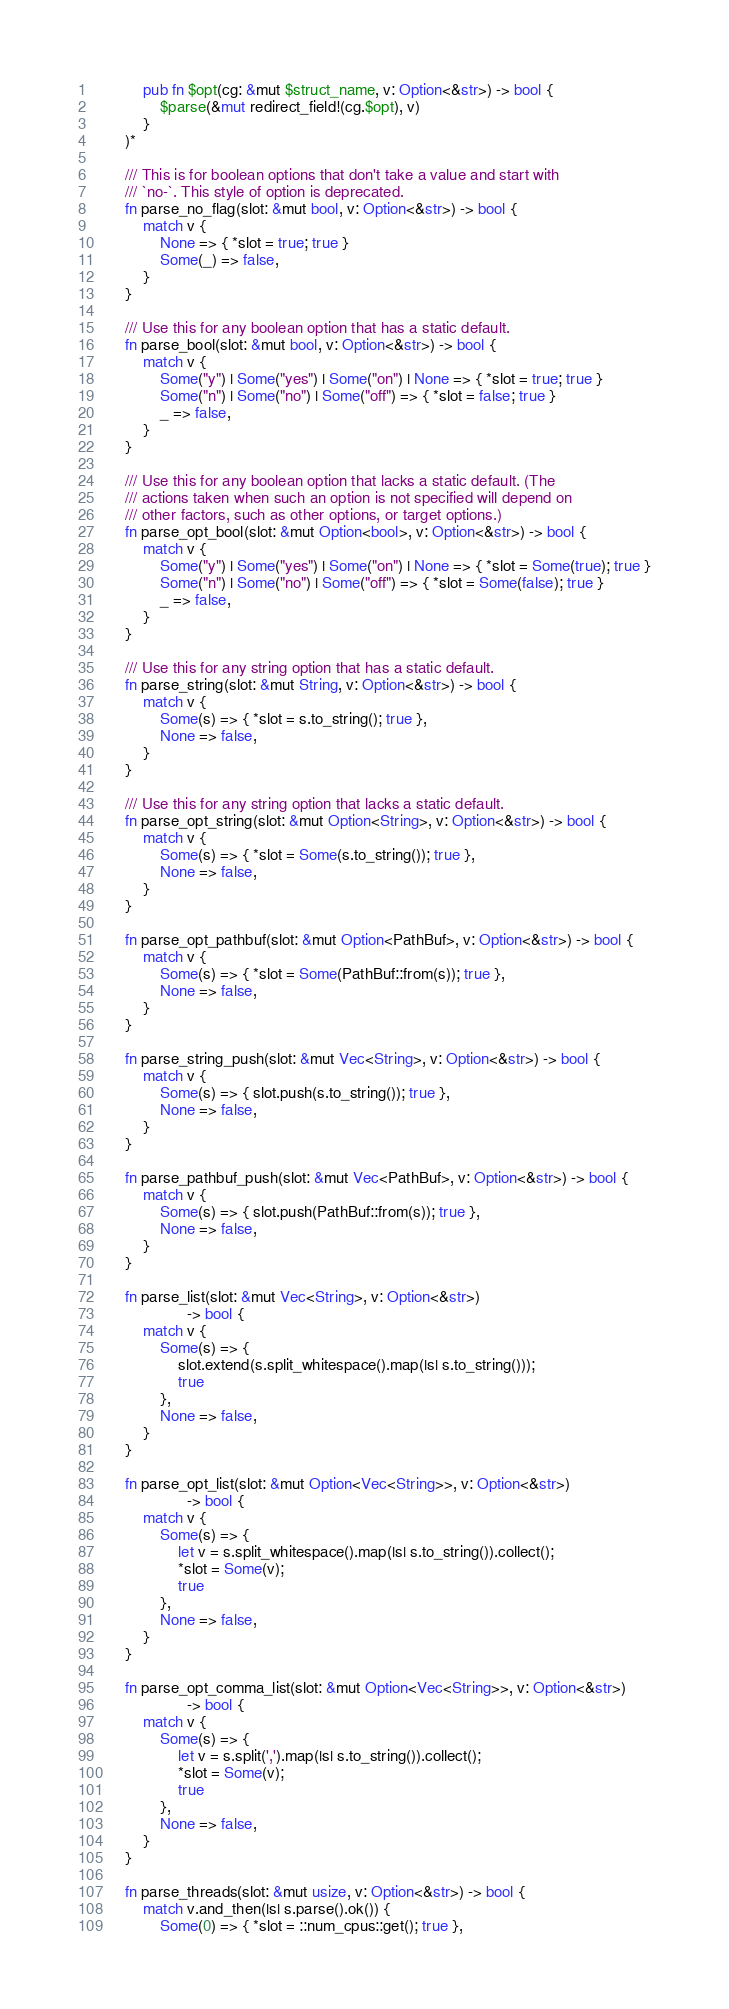Convert code to text. <code><loc_0><loc_0><loc_500><loc_500><_Rust_>            pub fn $opt(cg: &mut $struct_name, v: Option<&str>) -> bool {
                $parse(&mut redirect_field!(cg.$opt), v)
            }
        )*

        /// This is for boolean options that don't take a value and start with
        /// `no-`. This style of option is deprecated.
        fn parse_no_flag(slot: &mut bool, v: Option<&str>) -> bool {
            match v {
                None => { *slot = true; true }
                Some(_) => false,
            }
        }

        /// Use this for any boolean option that has a static default.
        fn parse_bool(slot: &mut bool, v: Option<&str>) -> bool {
            match v {
                Some("y") | Some("yes") | Some("on") | None => { *slot = true; true }
                Some("n") | Some("no") | Some("off") => { *slot = false; true }
                _ => false,
            }
        }

        /// Use this for any boolean option that lacks a static default. (The
        /// actions taken when such an option is not specified will depend on
        /// other factors, such as other options, or target options.)
        fn parse_opt_bool(slot: &mut Option<bool>, v: Option<&str>) -> bool {
            match v {
                Some("y") | Some("yes") | Some("on") | None => { *slot = Some(true); true }
                Some("n") | Some("no") | Some("off") => { *slot = Some(false); true }
                _ => false,
            }
        }

        /// Use this for any string option that has a static default.
        fn parse_string(slot: &mut String, v: Option<&str>) -> bool {
            match v {
                Some(s) => { *slot = s.to_string(); true },
                None => false,
            }
        }

        /// Use this for any string option that lacks a static default.
        fn parse_opt_string(slot: &mut Option<String>, v: Option<&str>) -> bool {
            match v {
                Some(s) => { *slot = Some(s.to_string()); true },
                None => false,
            }
        }

        fn parse_opt_pathbuf(slot: &mut Option<PathBuf>, v: Option<&str>) -> bool {
            match v {
                Some(s) => { *slot = Some(PathBuf::from(s)); true },
                None => false,
            }
        }

        fn parse_string_push(slot: &mut Vec<String>, v: Option<&str>) -> bool {
            match v {
                Some(s) => { slot.push(s.to_string()); true },
                None => false,
            }
        }

        fn parse_pathbuf_push(slot: &mut Vec<PathBuf>, v: Option<&str>) -> bool {
            match v {
                Some(s) => { slot.push(PathBuf::from(s)); true },
                None => false,
            }
        }

        fn parse_list(slot: &mut Vec<String>, v: Option<&str>)
                      -> bool {
            match v {
                Some(s) => {
                    slot.extend(s.split_whitespace().map(|s| s.to_string()));
                    true
                },
                None => false,
            }
        }

        fn parse_opt_list(slot: &mut Option<Vec<String>>, v: Option<&str>)
                      -> bool {
            match v {
                Some(s) => {
                    let v = s.split_whitespace().map(|s| s.to_string()).collect();
                    *slot = Some(v);
                    true
                },
                None => false,
            }
        }

        fn parse_opt_comma_list(slot: &mut Option<Vec<String>>, v: Option<&str>)
                      -> bool {
            match v {
                Some(s) => {
                    let v = s.split(',').map(|s| s.to_string()).collect();
                    *slot = Some(v);
                    true
                },
                None => false,
            }
        }

        fn parse_threads(slot: &mut usize, v: Option<&str>) -> bool {
            match v.and_then(|s| s.parse().ok()) {
                Some(0) => { *slot = ::num_cpus::get(); true },</code> 